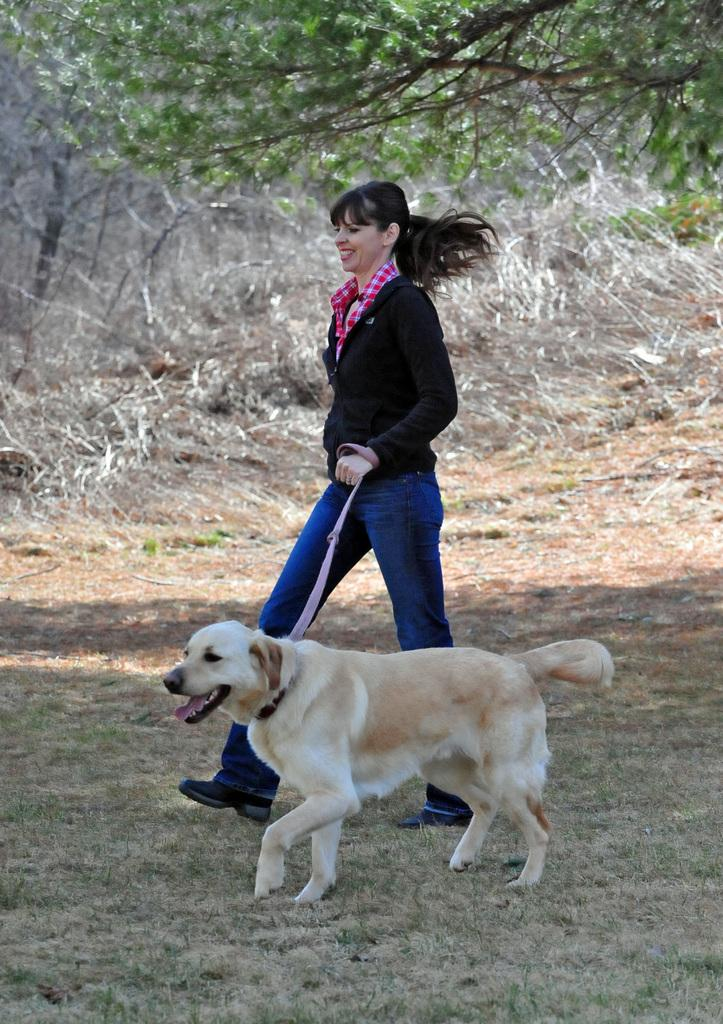Who is present in the image? There is a woman in the image. What is the woman doing in the image? The woman is walking in the image. What is the woman holding while walking? The woman is holding a dog's leash in the image. What is the dog doing in the image? The dog is walking beside the woman in the image. What can be seen in the background of the image? There are many trees in the image. What type of magic is the woman performing on the dog in the image? There is no magic present in the image; the woman is simply walking with the dog on a leash. 